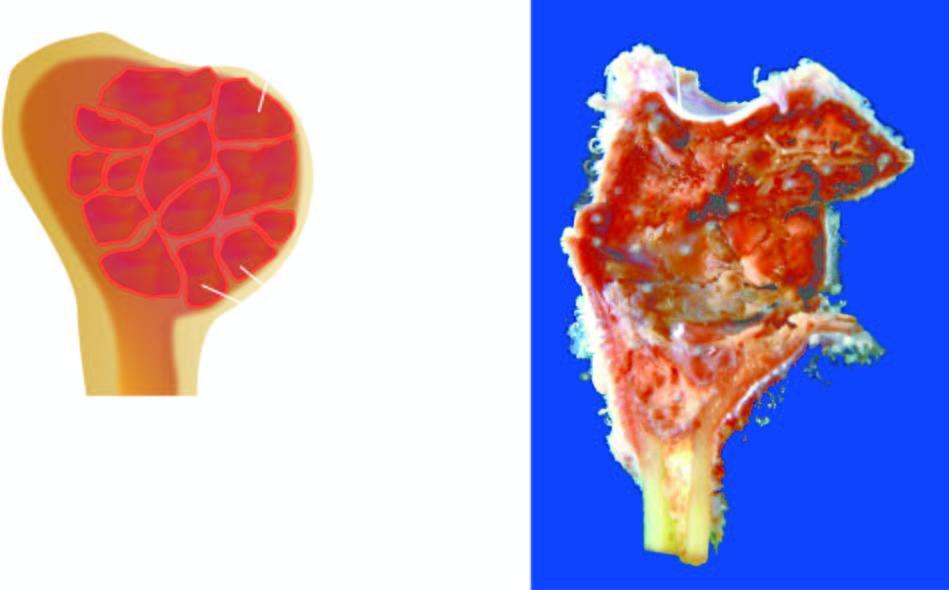why is the end of the long bone expanded?
Answer the question using a single word or phrase. Due to a cyst 